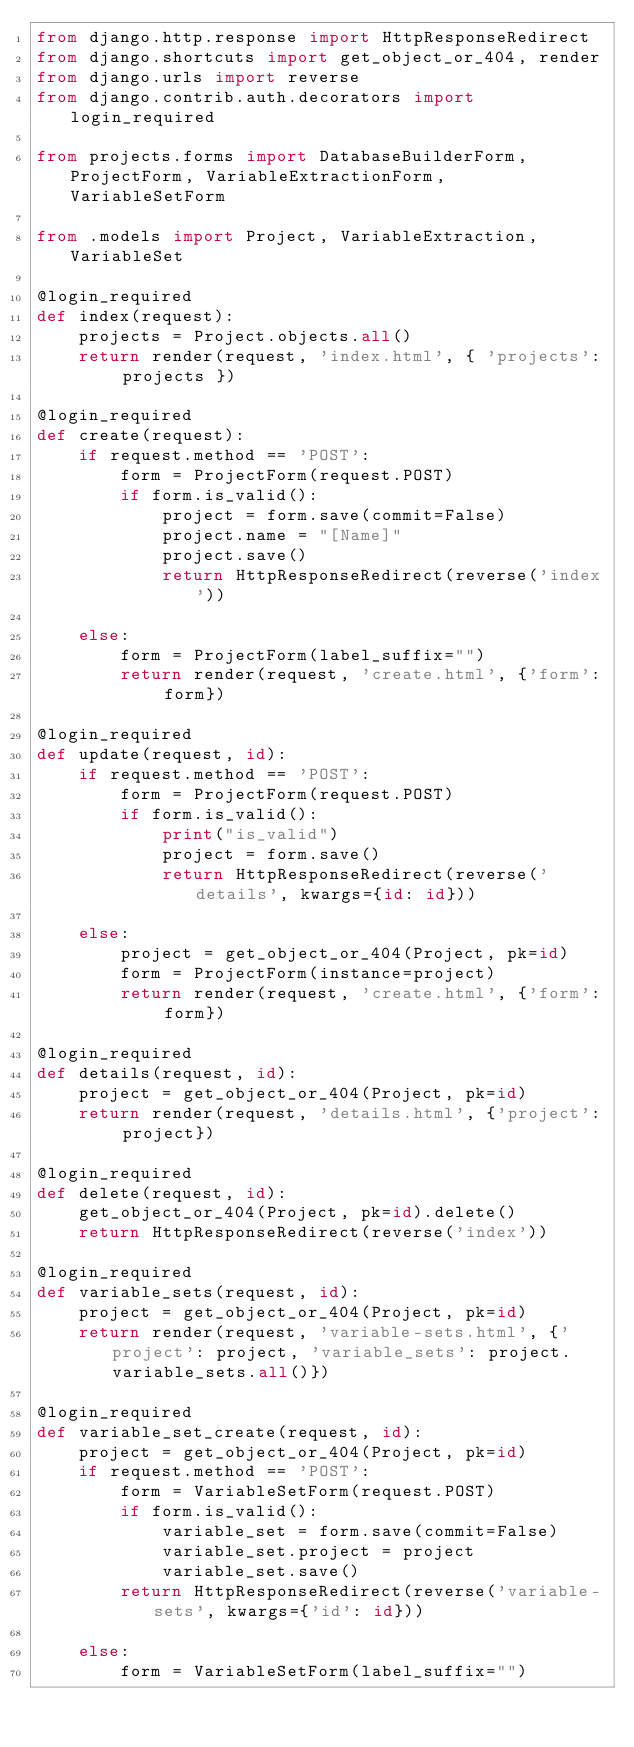Convert code to text. <code><loc_0><loc_0><loc_500><loc_500><_Python_>from django.http.response import HttpResponseRedirect
from django.shortcuts import get_object_or_404, render
from django.urls import reverse
from django.contrib.auth.decorators import login_required

from projects.forms import DatabaseBuilderForm, ProjectForm, VariableExtractionForm, VariableSetForm

from .models import Project, VariableExtraction, VariableSet

@login_required
def index(request):
    projects = Project.objects.all()
    return render(request, 'index.html', { 'projects': projects })

@login_required
def create(request):
    if request.method == 'POST':
        form = ProjectForm(request.POST)
        if form.is_valid():
            project = form.save(commit=False)
            project.name = "[Name]"
            project.save()
            return HttpResponseRedirect(reverse('index'))
    
    else:
        form = ProjectForm(label_suffix="")
        return render(request, 'create.html', {'form': form})

@login_required
def update(request, id):
    if request.method == 'POST':
        form = ProjectForm(request.POST)
        if form.is_valid():
            print("is_valid")
            project = form.save()
            return HttpResponseRedirect(reverse('details', kwargs={id: id}))
    
    else:
        project = get_object_or_404(Project, pk=id)
        form = ProjectForm(instance=project)
        return render(request, 'create.html', {'form': form})

@login_required
def details(request, id):
    project = get_object_or_404(Project, pk=id)
    return render(request, 'details.html', {'project': project})

@login_required
def delete(request, id):
    get_object_or_404(Project, pk=id).delete()
    return HttpResponseRedirect(reverse('index'))

@login_required
def variable_sets(request, id):
    project = get_object_or_404(Project, pk=id)
    return render(request, 'variable-sets.html', {'project': project, 'variable_sets': project.variable_sets.all()})

@login_required
def variable_set_create(request, id):
    project = get_object_or_404(Project, pk=id)
    if request.method == 'POST':
        form = VariableSetForm(request.POST)
        if form.is_valid():
            variable_set = form.save(commit=False)
            variable_set.project = project
            variable_set.save()
        return HttpResponseRedirect(reverse('variable-sets', kwargs={'id': id}))

    else:
        form = VariableSetForm(label_suffix="")</code> 